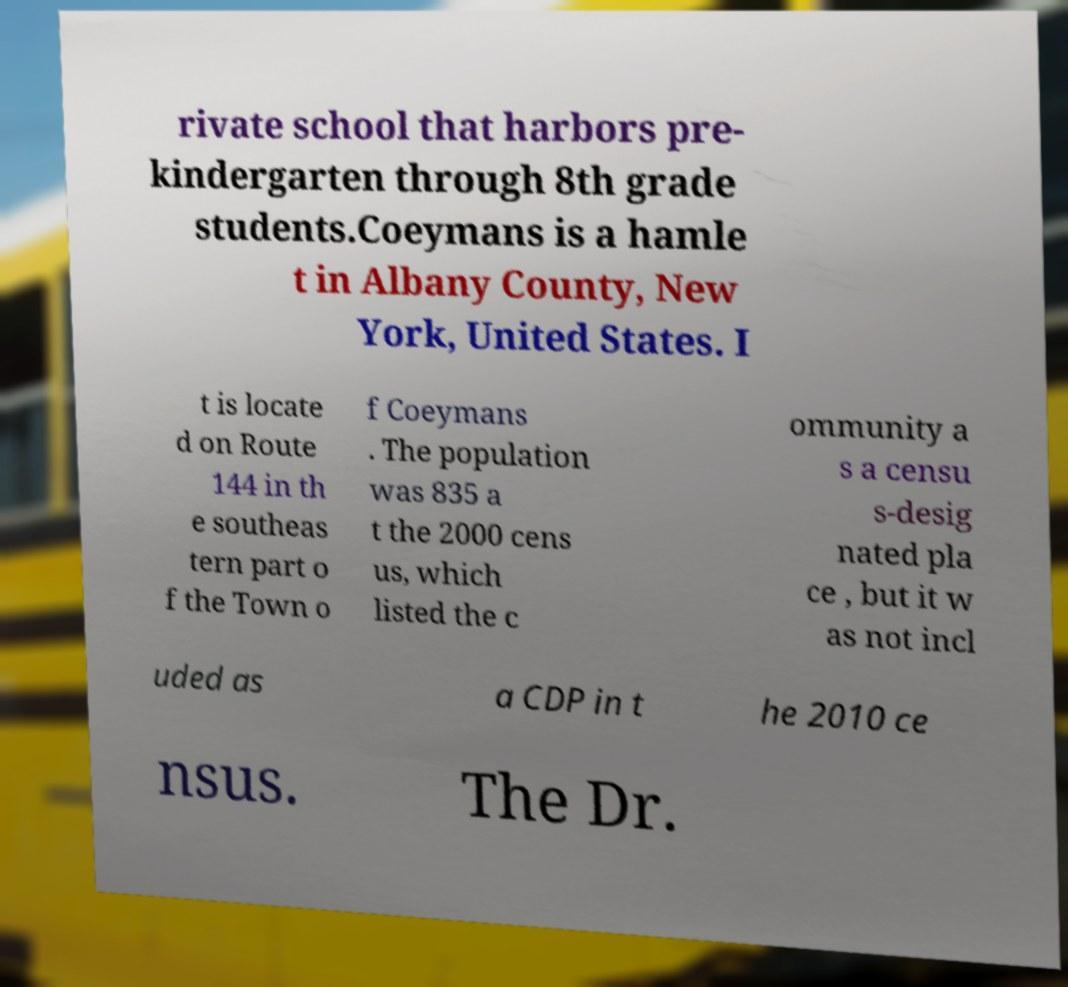For documentation purposes, I need the text within this image transcribed. Could you provide that? rivate school that harbors pre- kindergarten through 8th grade students.Coeymans is a hamle t in Albany County, New York, United States. I t is locate d on Route 144 in th e southeas tern part o f the Town o f Coeymans . The population was 835 a t the 2000 cens us, which listed the c ommunity a s a censu s-desig nated pla ce , but it w as not incl uded as a CDP in t he 2010 ce nsus. The Dr. 